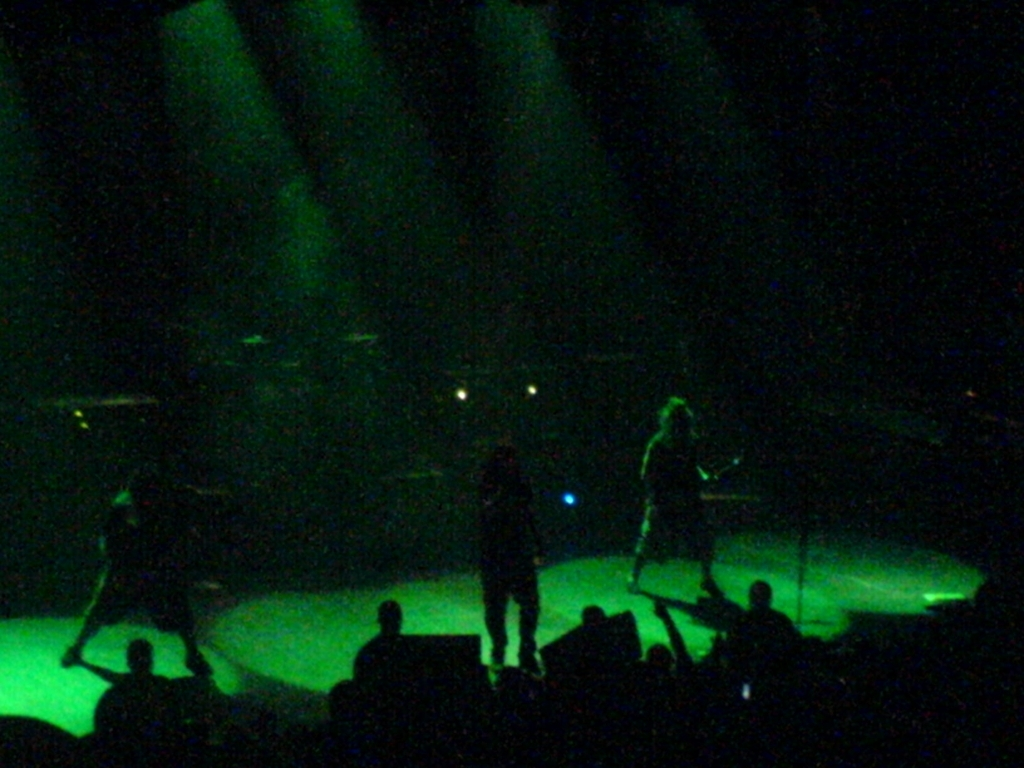What kind of event is captured in this image? The image depicts a live music performance, recognizable by the stage lights and the silhouettes of the performing musicians. 